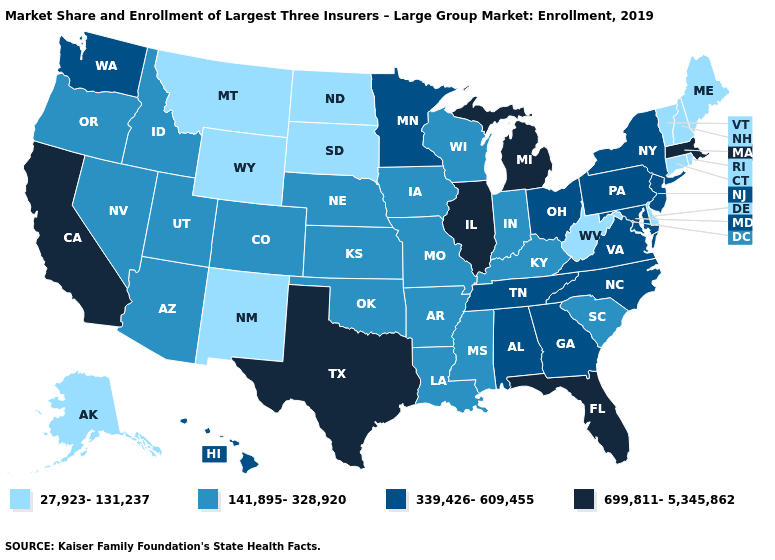What is the highest value in states that border Idaho?
Concise answer only. 339,426-609,455. Is the legend a continuous bar?
Concise answer only. No. Does Texas have the same value as Illinois?
Be succinct. Yes. What is the value of Pennsylvania?
Answer briefly. 339,426-609,455. Does Texas have the highest value in the USA?
Answer briefly. Yes. What is the value of New Hampshire?
Concise answer only. 27,923-131,237. What is the highest value in the USA?
Keep it brief. 699,811-5,345,862. What is the value of Nebraska?
Write a very short answer. 141,895-328,920. Does California have the highest value in the West?
Write a very short answer. Yes. Name the states that have a value in the range 339,426-609,455?
Short answer required. Alabama, Georgia, Hawaii, Maryland, Minnesota, New Jersey, New York, North Carolina, Ohio, Pennsylvania, Tennessee, Virginia, Washington. Name the states that have a value in the range 339,426-609,455?
Keep it brief. Alabama, Georgia, Hawaii, Maryland, Minnesota, New Jersey, New York, North Carolina, Ohio, Pennsylvania, Tennessee, Virginia, Washington. Among the states that border Georgia , does South Carolina have the lowest value?
Give a very brief answer. Yes. Name the states that have a value in the range 339,426-609,455?
Short answer required. Alabama, Georgia, Hawaii, Maryland, Minnesota, New Jersey, New York, North Carolina, Ohio, Pennsylvania, Tennessee, Virginia, Washington. What is the value of Minnesota?
Give a very brief answer. 339,426-609,455. Is the legend a continuous bar?
Short answer required. No. 